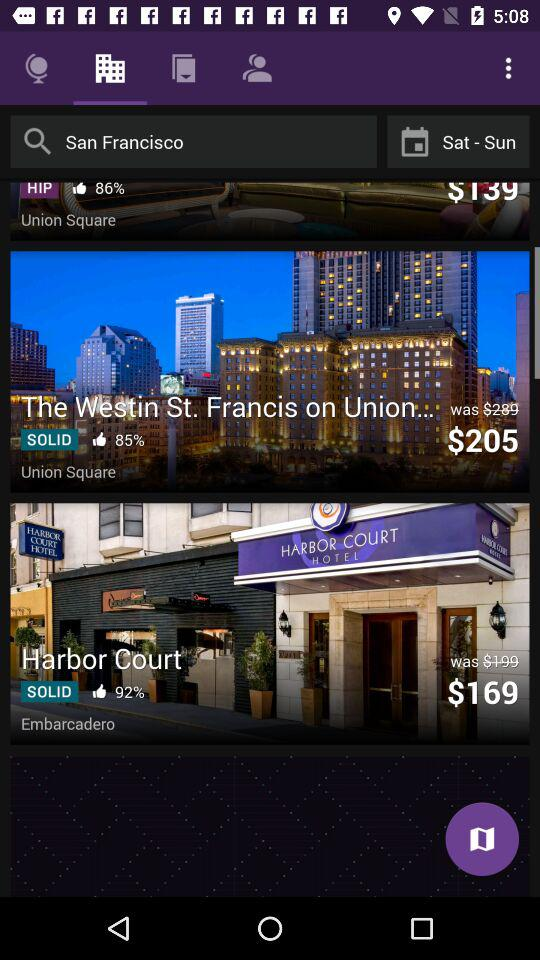What is the price of "Harbor Court"? The price of "Harbor Court" is $169. 